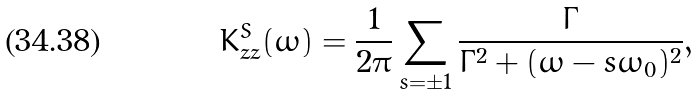<formula> <loc_0><loc_0><loc_500><loc_500>K _ { z z } ^ { S } ( \omega ) = \frac { 1 } { 2 \pi } \sum _ { s = \pm 1 } \frac { \Gamma } { \Gamma ^ { 2 } + ( \omega - s \omega _ { 0 } ) ^ { 2 } } ,</formula> 